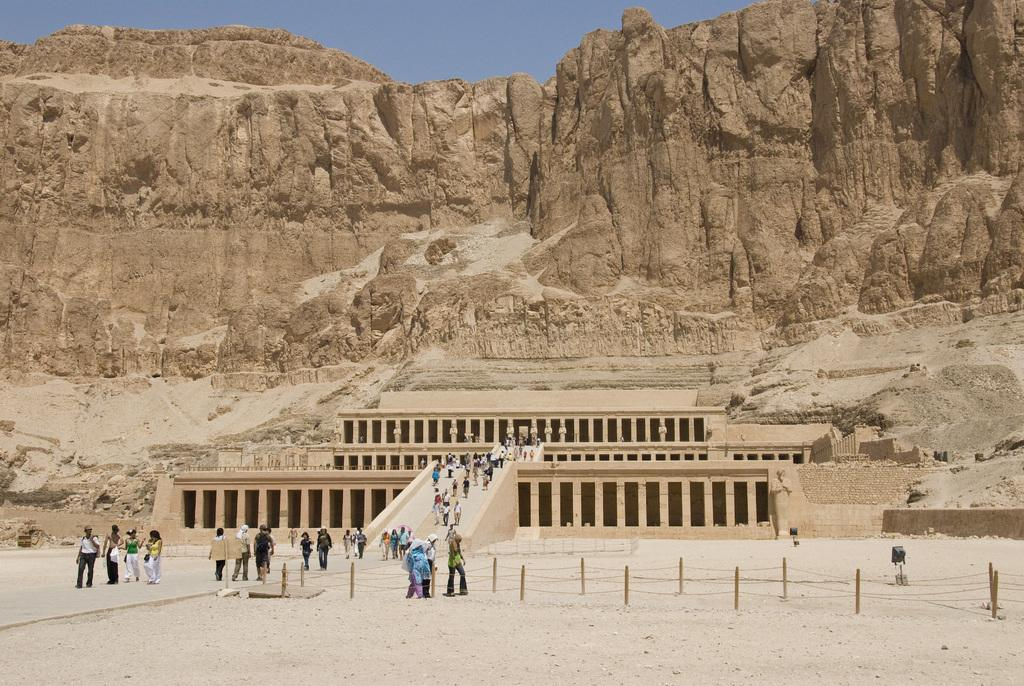How many people can be seen in the image? There are many people in the image. What are the people doing in the image? The people are walking on a path. Where does the path lead to? The path leads to a building. How is the building situated in the image? The building is engraved on a mountain. What can be seen above the mountain in the image? The sky is visible above the mountain. What type of mint can be seen growing near the crib in the image? There is no crib or mint present in the image. What material is the brass used for in the image? There is no brass present in the image. 